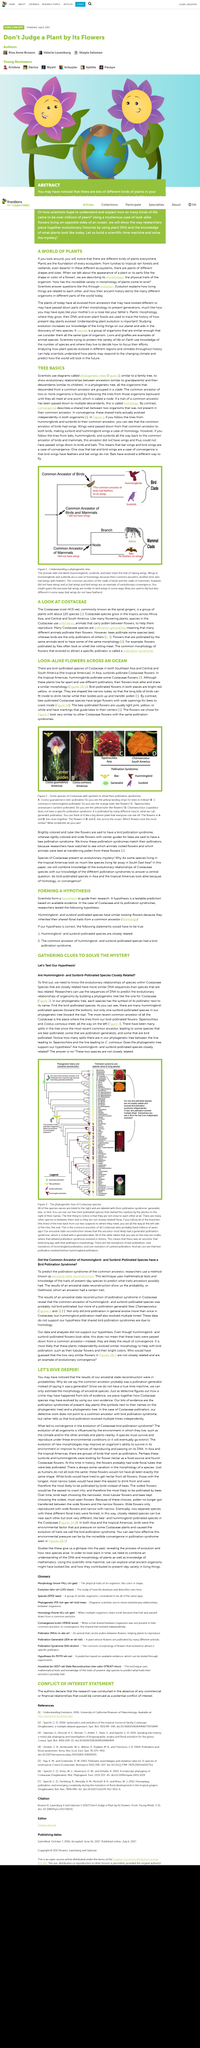Specify some key components in this picture. Since scientists can only estimate the morphology of a fossil, they often talk about probabilities when describing its characteristics. The research focuses on Costaceae species because they are being studied. The article's subject is the Costaceae family of plants, also known as spiral gingers, and the article provides a look at this family of plants. Costaceae species are found in the tropics across Africa, Asia, and Central and South America, where they commonly grow. The term "morphology" refers to the physical traits of an organism. 